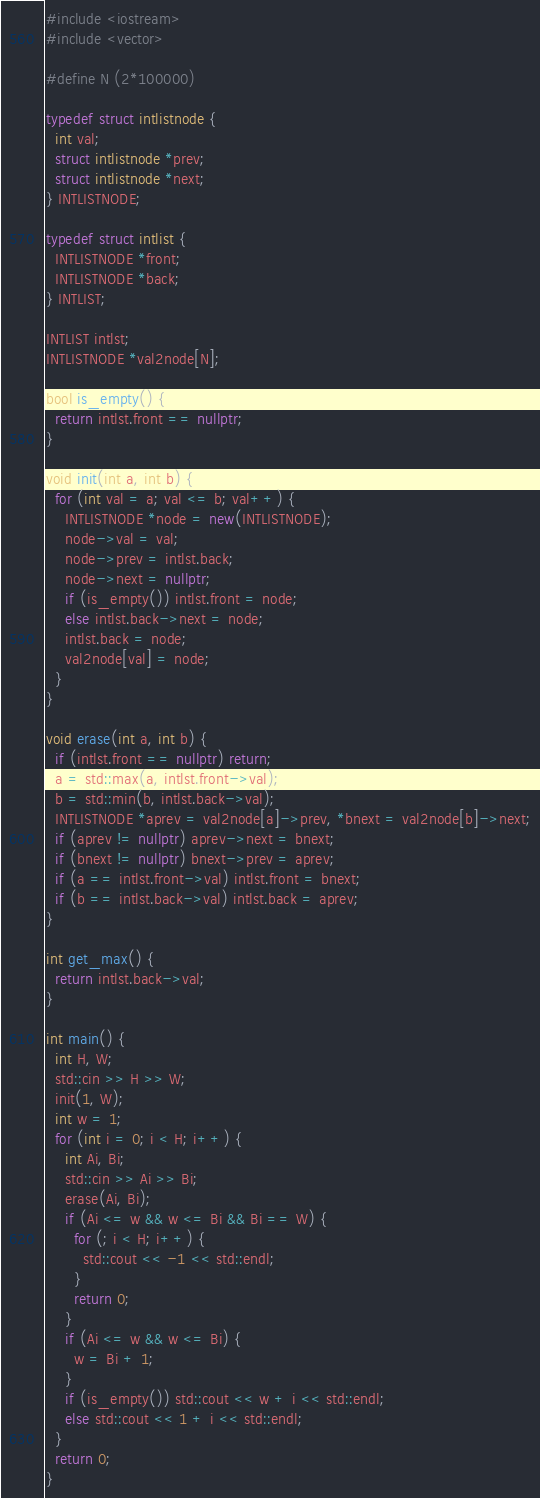Convert code to text. <code><loc_0><loc_0><loc_500><loc_500><_C++_>#include <iostream>
#include <vector>

#define N (2*100000)

typedef struct intlistnode {
  int val;
  struct intlistnode *prev;
  struct intlistnode *next;
} INTLISTNODE;

typedef struct intlist {
  INTLISTNODE *front;
  INTLISTNODE *back;
} INTLIST;

INTLIST intlst;
INTLISTNODE *val2node[N];

bool is_empty() {
  return intlst.front == nullptr;
}

void init(int a, int b) {
  for (int val = a; val <= b; val++) {
    INTLISTNODE *node = new(INTLISTNODE);
    node->val = val;
    node->prev = intlst.back;
    node->next = nullptr;
    if (is_empty()) intlst.front = node;
    else intlst.back->next = node;
    intlst.back = node;
    val2node[val] = node;
  }
}

void erase(int a, int b) {
  if (intlst.front == nullptr) return;
  a = std::max(a, intlst.front->val);
  b = std::min(b, intlst.back->val);
  INTLISTNODE *aprev = val2node[a]->prev, *bnext = val2node[b]->next;
  if (aprev != nullptr) aprev->next = bnext;
  if (bnext != nullptr) bnext->prev = aprev;
  if (a == intlst.front->val) intlst.front = bnext;
  if (b == intlst.back->val) intlst.back = aprev;
}

int get_max() {
  return intlst.back->val;
}

int main() {
  int H, W;
  std::cin >> H >> W;
  init(1, W);
  int w = 1;
  for (int i = 0; i < H; i++) {
    int Ai, Bi;
    std::cin >> Ai >> Bi;
    erase(Ai, Bi);
    if (Ai <= w && w <= Bi && Bi == W) {
      for (; i < H; i++) {
        std::cout << -1 << std::endl;
      }
      return 0;
    }
    if (Ai <= w && w <= Bi) {
      w = Bi + 1;
    }
    if (is_empty()) std::cout << w + i << std::endl;
    else std::cout << 1 + i << std::endl;
  }
  return 0;
}
</code> 